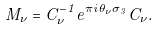Convert formula to latex. <formula><loc_0><loc_0><loc_500><loc_500>M _ { \nu } = C ^ { - 1 } _ { \nu } e ^ { \pi i \theta _ { \nu } \sigma _ { 3 } } C _ { \nu } .</formula> 